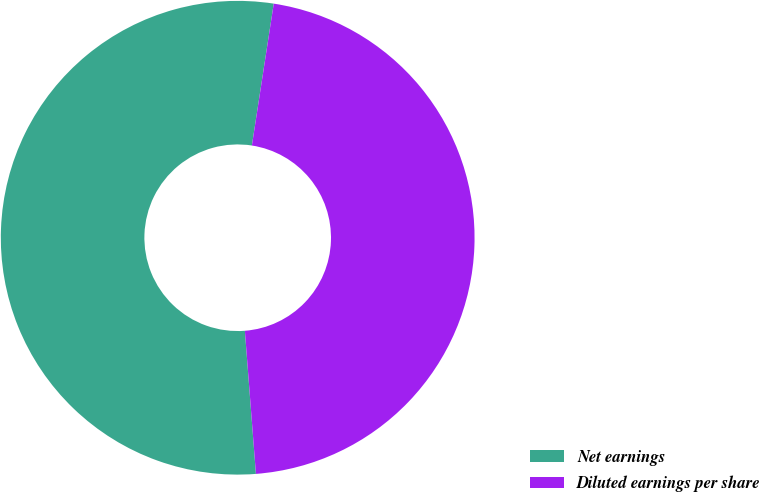<chart> <loc_0><loc_0><loc_500><loc_500><pie_chart><fcel>Net earnings<fcel>Diluted earnings per share<nl><fcel>53.66%<fcel>46.34%<nl></chart> 